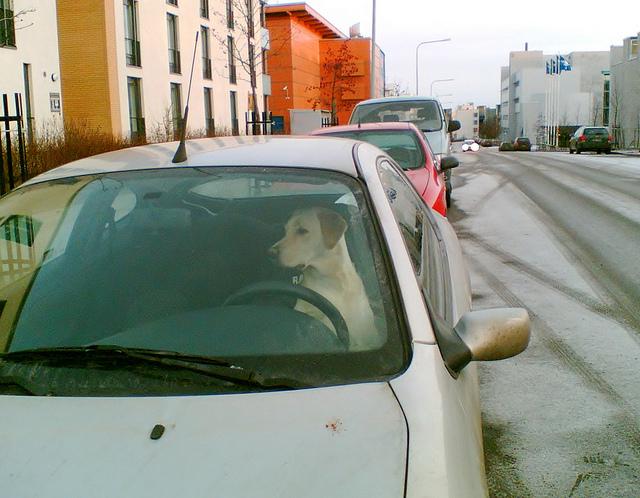How many dogs in the car?
Answer briefly. 1. Do you see a red car?
Answer briefly. Yes. Is this dog driving the car?
Quick response, please. No. What is shining in the background?
Concise answer only. Headlights. 